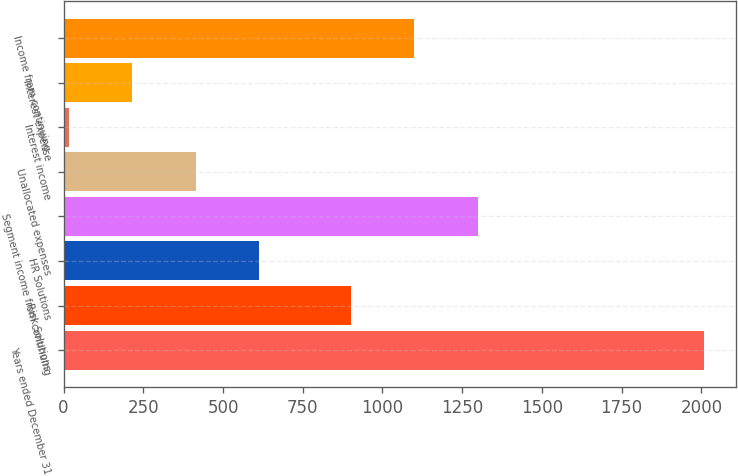Convert chart. <chart><loc_0><loc_0><loc_500><loc_500><bar_chart><fcel>Years ended December 31<fcel>Risk Solutions<fcel>HR Solutions<fcel>Segment income from continuing<fcel>Unallocated expenses<fcel>Interest income<fcel>Interest expense<fcel>Income from continuing<nl><fcel>2009<fcel>900<fcel>613.9<fcel>1298.6<fcel>414.6<fcel>16<fcel>215.3<fcel>1099.3<nl></chart> 